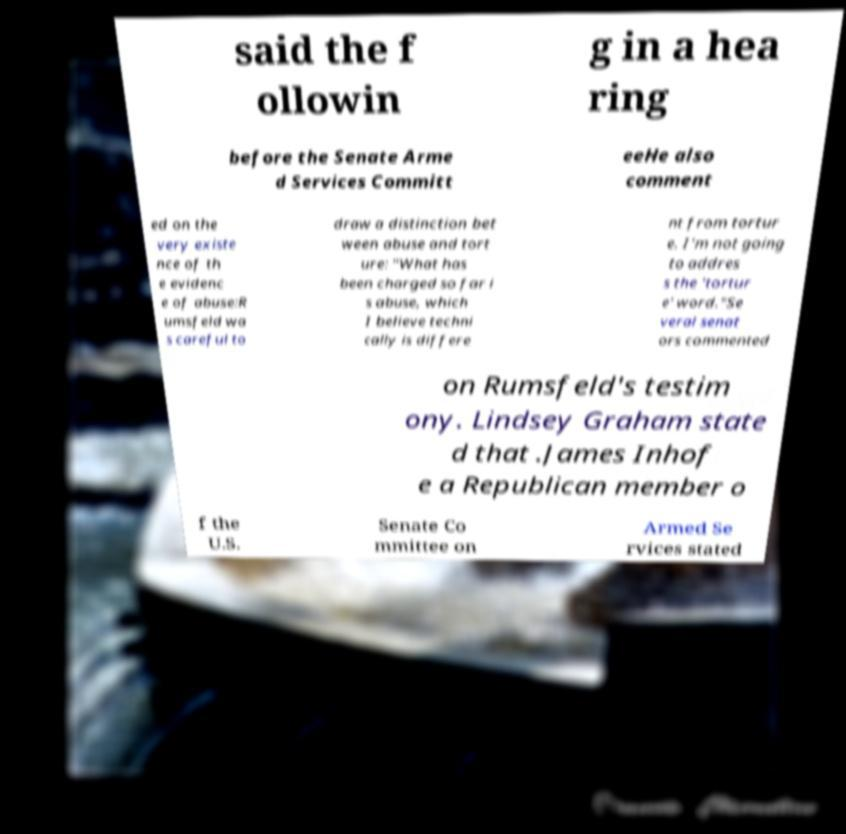Please read and relay the text visible in this image. What does it say? said the f ollowin g in a hea ring before the Senate Arme d Services Committ eeHe also comment ed on the very existe nce of th e evidenc e of abuse:R umsfeld wa s careful to draw a distinction bet ween abuse and tort ure: "What has been charged so far i s abuse, which I believe techni cally is differe nt from tortur e. I'm not going to addres s the 'tortur e' word."Se veral senat ors commented on Rumsfeld's testim ony. Lindsey Graham state d that .James Inhof e a Republican member o f the U.S. Senate Co mmittee on Armed Se rvices stated 